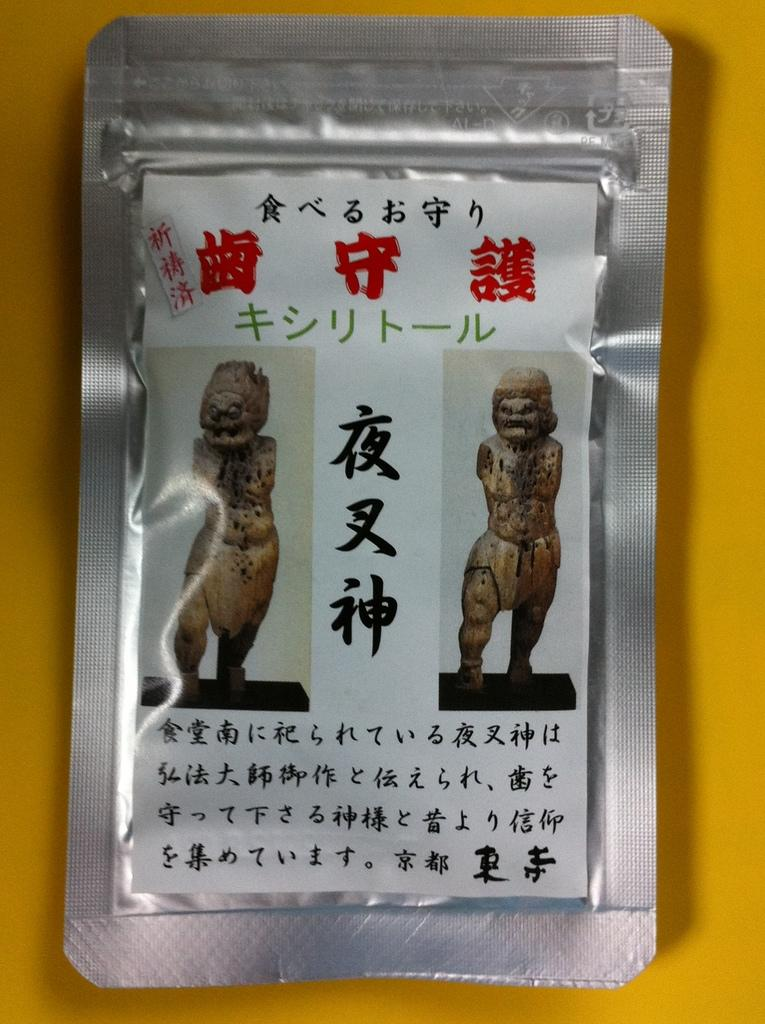What is the main feature of the image? There is a surface in the image. What can be found on the surface? There are statues and text on the surface. What color is the background of the image? The background of the image is yellow. What type of crib is visible in the image? There is no crib present in the image. What medical advice is the doctor giving in the image? There is no doctor present in the image. 